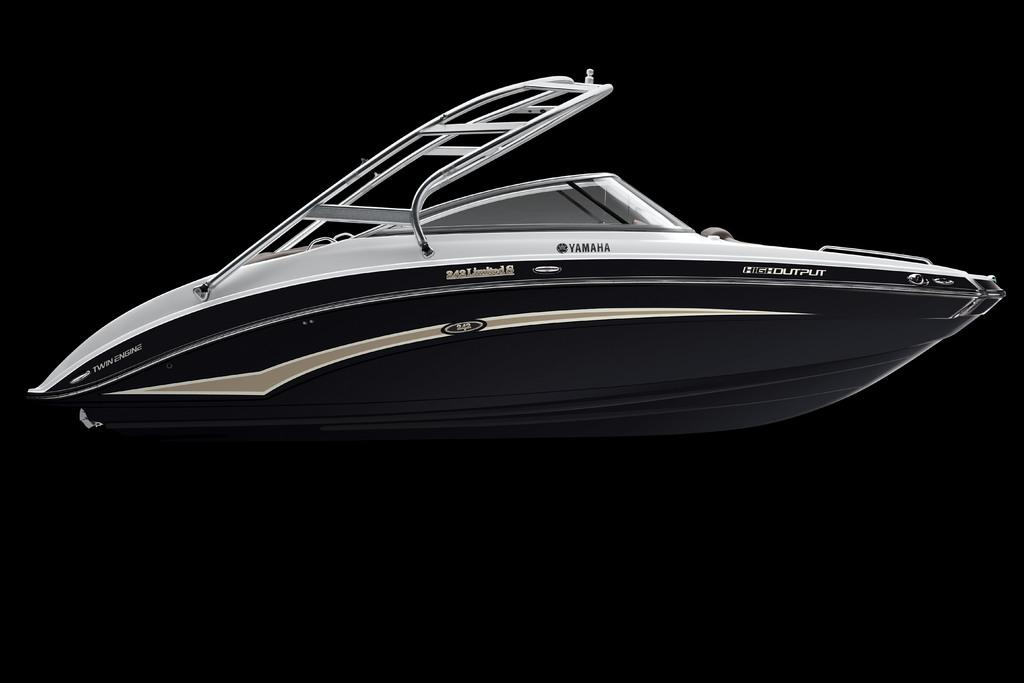Provide a one-sentence caption for the provided image. A gray and silver Yamaha speed boat is shown on its side against the black background. 